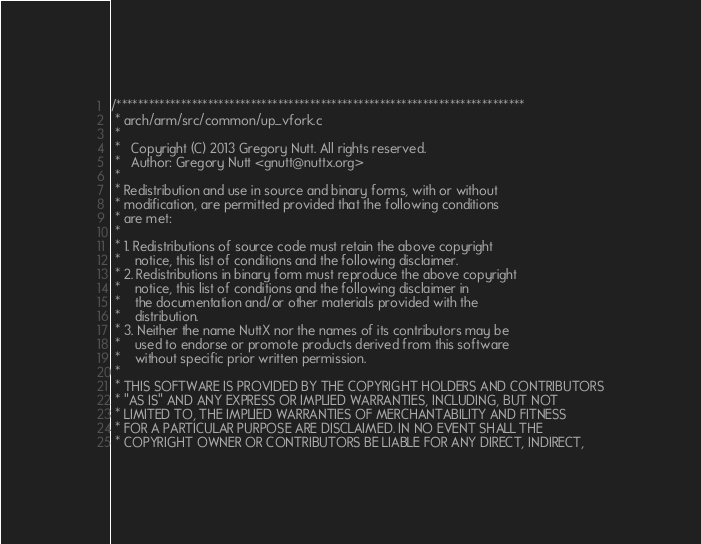Convert code to text. <code><loc_0><loc_0><loc_500><loc_500><_C_>/****************************************************************************
 * arch/arm/src/common/up_vfork.c
 *
 *   Copyright (C) 2013 Gregory Nutt. All rights reserved.
 *   Author: Gregory Nutt <gnutt@nuttx.org>
 *
 * Redistribution and use in source and binary forms, with or without
 * modification, are permitted provided that the following conditions
 * are met:
 *
 * 1. Redistributions of source code must retain the above copyright
 *    notice, this list of conditions and the following disclaimer.
 * 2. Redistributions in binary form must reproduce the above copyright
 *    notice, this list of conditions and the following disclaimer in
 *    the documentation and/or other materials provided with the
 *    distribution.
 * 3. Neither the name NuttX nor the names of its contributors may be
 *    used to endorse or promote products derived from this software
 *    without specific prior written permission.
 *
 * THIS SOFTWARE IS PROVIDED BY THE COPYRIGHT HOLDERS AND CONTRIBUTORS
 * "AS IS" AND ANY EXPRESS OR IMPLIED WARRANTIES, INCLUDING, BUT NOT
 * LIMITED TO, THE IMPLIED WARRANTIES OF MERCHANTABILITY AND FITNESS
 * FOR A PARTICULAR PURPOSE ARE DISCLAIMED. IN NO EVENT SHALL THE
 * COPYRIGHT OWNER OR CONTRIBUTORS BE LIABLE FOR ANY DIRECT, INDIRECT,</code> 